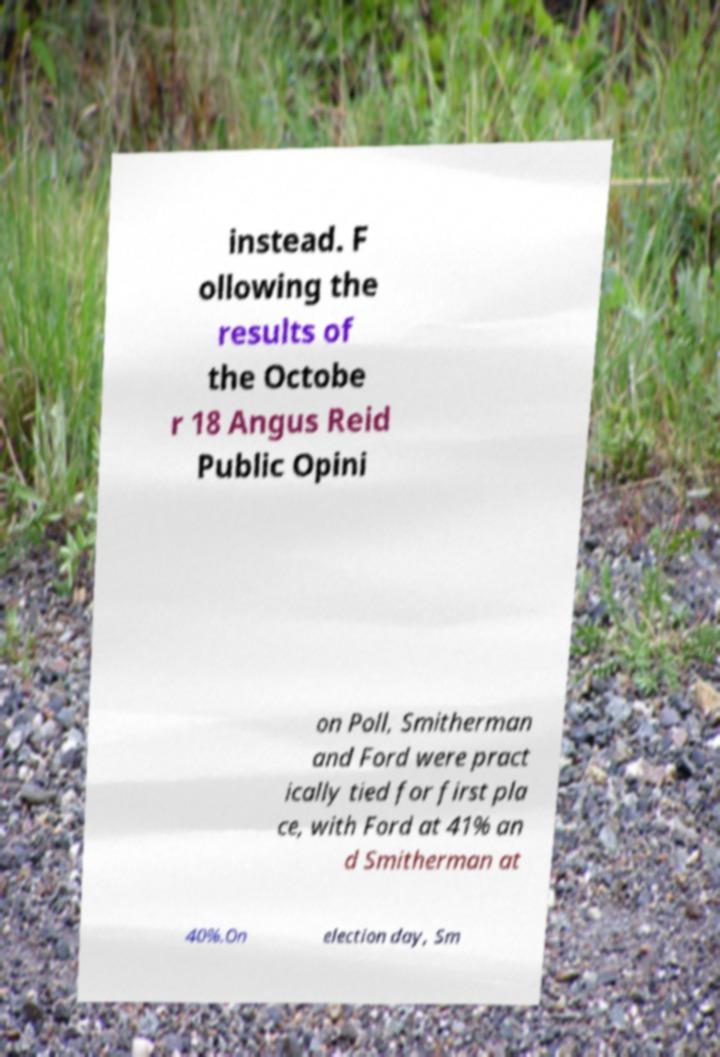I need the written content from this picture converted into text. Can you do that? instead. F ollowing the results of the Octobe r 18 Angus Reid Public Opini on Poll, Smitherman and Ford were pract ically tied for first pla ce, with Ford at 41% an d Smitherman at 40%.On election day, Sm 